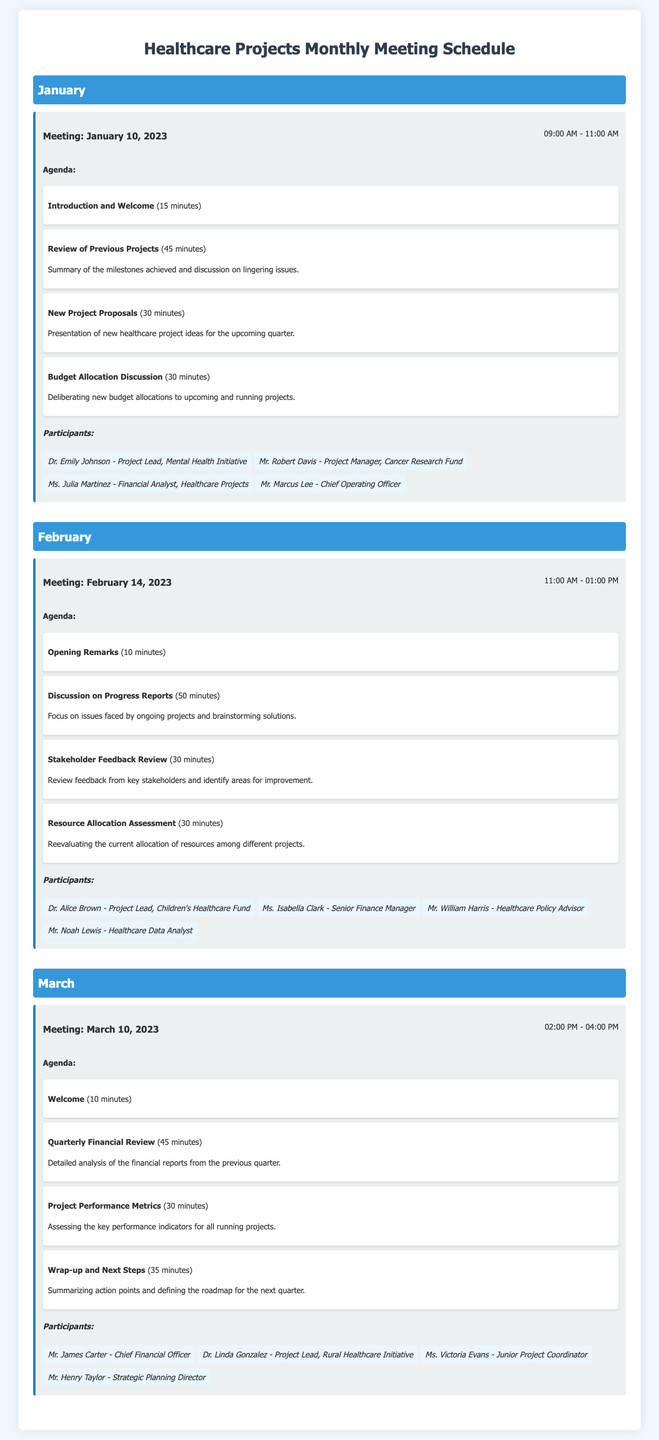What is the date of the January meeting? The document lists January meeting date as January 10, 2023.
Answer: January 10, 2023 How long is the February meeting scheduled for? The duration of the February meeting is indicated as 11:00 AM - 01:00 PM, which is 2 hours.
Answer: 2 hours Who is the Project Lead for the Mental Health Initiative? According to the participant list for January, Dr. Emily Johnson is the Project Lead for the Mental Health Initiative.
Answer: Dr. Emily Johnson What is the main topic discussed in the March meeting regarding financials? The March meeting agenda includes a detailed analysis of the financial reports from the previous quarter, identified as "Quarterly Financial Review".
Answer: Quarterly Financial Review How many participants are listed for the February meeting? The document specifies that there are four participants attending the February meeting.
Answer: Four participants Which project was discussed regarding resource allocation in the February meeting? The February agenda includes a "Resource Allocation Assessment," which evaluates resources among different projects.
Answer: Resource Allocation Assessment What is the first agenda item for the January meeting? The document states the first agenda item is "Introduction and Welcome," which takes 15 minutes.
Answer: Introduction and Welcome In which month is the "Wrap-up and Next Steps" agenda item scheduled? The "Wrap-up and Next Steps" item is the last agenda discussed in the March meeting.
Answer: March 